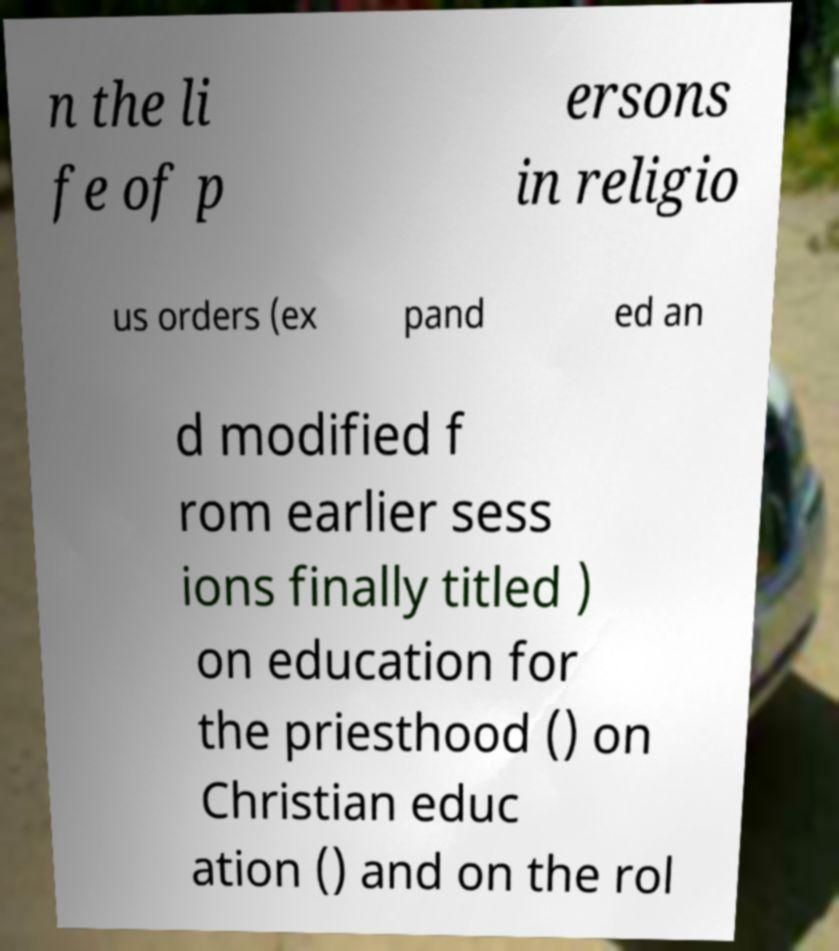There's text embedded in this image that I need extracted. Can you transcribe it verbatim? n the li fe of p ersons in religio us orders (ex pand ed an d modified f rom earlier sess ions finally titled ) on education for the priesthood () on Christian educ ation () and on the rol 